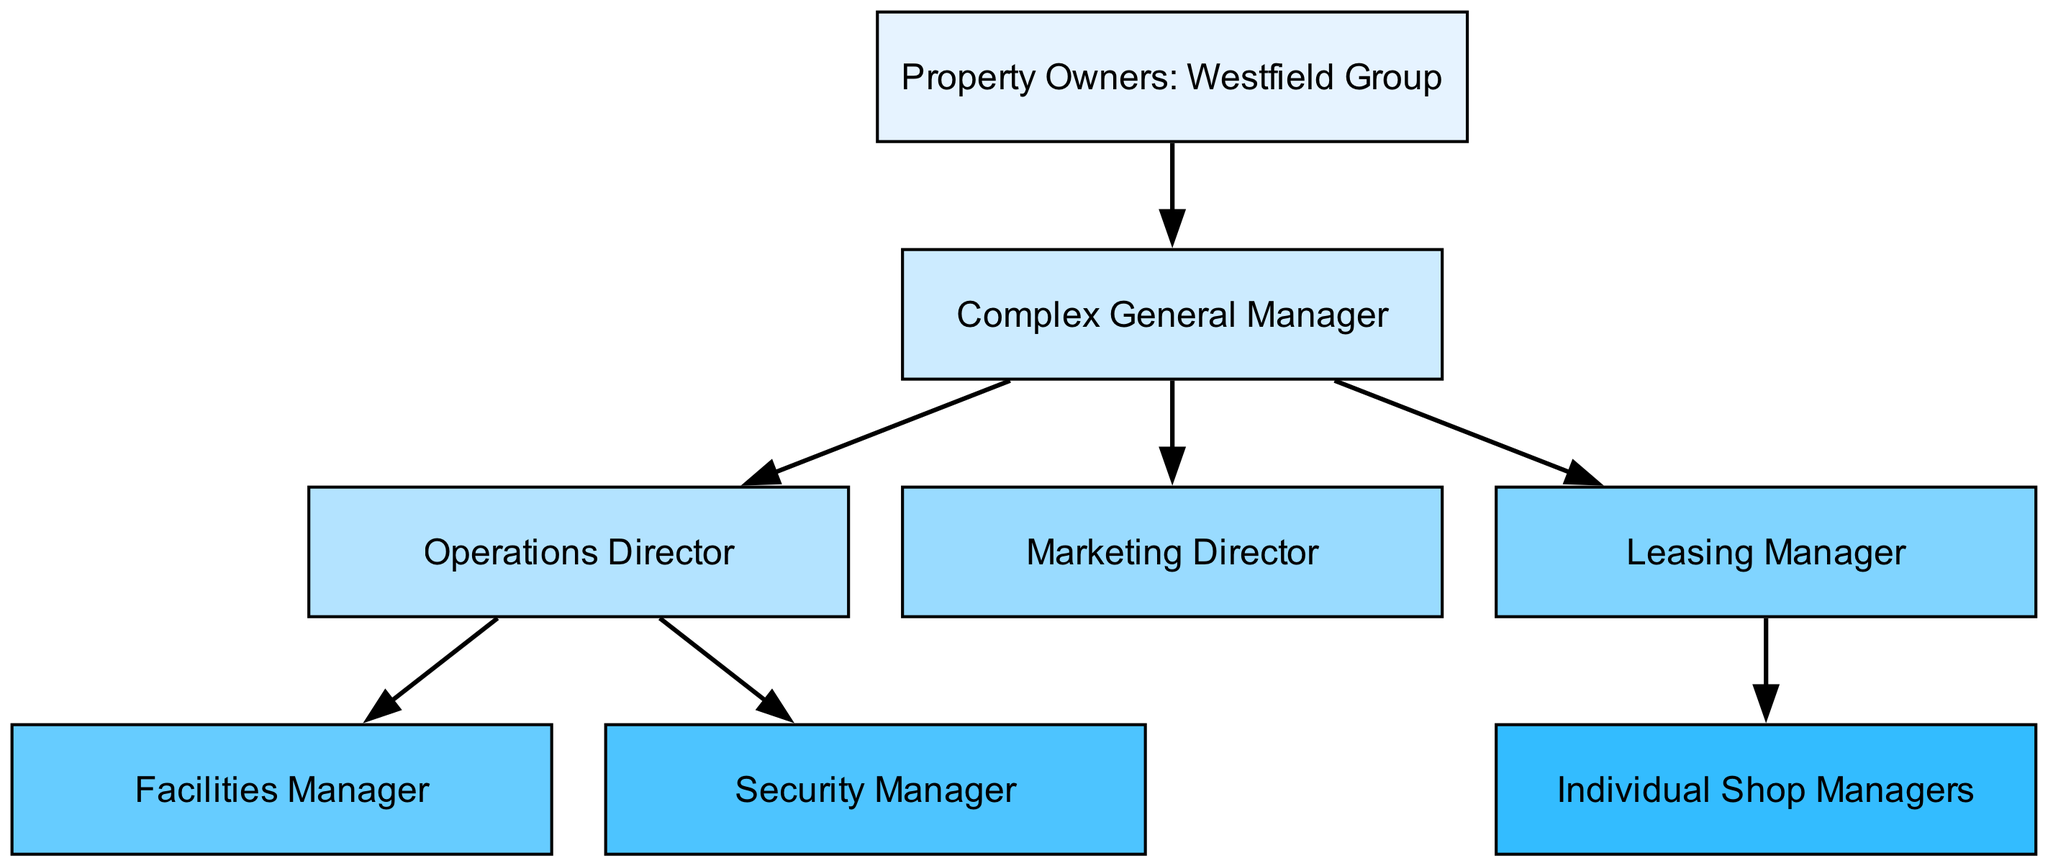What is the top-level node in the hierarchy? The top-level node represents the highest authority in the hierarchy, which is the "Property Owners: Westfield Group". It sits at the top of the chart and connects to the general manager.
Answer: Property Owners: Westfield Group How many total nodes are there in the diagram? To determine the total number of nodes, we count each unique entity listed in the diagram. The nodes include the Property Owners, General Manager, Directors, Managers, and Shop Managers, totaling eight distinct nodes.
Answer: 8 Who reports directly to the Complex General Manager? The diagram shows three nodes that are connected directly to the Complex General Manager: the Operations Director, the Marketing Director, and the Leasing Manager. These nodes represent the management that reports straight to the General Manager.
Answer: Operations Director, Marketing Director, Leasing Manager What position is responsible for security in the complex? The Security Manager is identified as the position responsible for security, linked under the Operations Director. The relationship indicates that the Security Manager is a subordinate role within the management structure.
Answer: Security Manager How many edges are there in the hierarchy? Edges indicate the relationships or reporting lines between the nodes in the diagram. By counting all the edges listed, we find there are six direct connections in the management structure.
Answer: 6 Which manager is responsible for overseeing individual shop operations? The Leasing Manager is positioned as the manager responsible for individual shop operations, as the connection shows they oversee the Individual Shop Managers. This indicates that the Leasing Manager is crucial for the management of shops in the complex.
Answer: Leasing Manager Which role is directly connected to the Facilities Manager? The diagram shows that the Facilities Manager is directly connected to the Operations Director. This relationship indicates the Facilities Manager's role falls under the oversight and management of the Operations Director.
Answer: Operations Director What is the relationship between the Property Owners and the Complex General Manager? The Property Owners (Westfield Group) have a direct reporting line to the Complex General Manager, indicating that the General Manager is accountable to the Property Owners for the operation of the complex.
Answer: Direct reporting line 